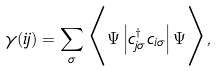Convert formula to latex. <formula><loc_0><loc_0><loc_500><loc_500>\gamma ( i j ) = \sum _ { \sigma } \Big < \Psi \left | c _ { j \sigma } ^ { \dag } c _ { i \sigma } \right | \Psi \Big > ,</formula> 